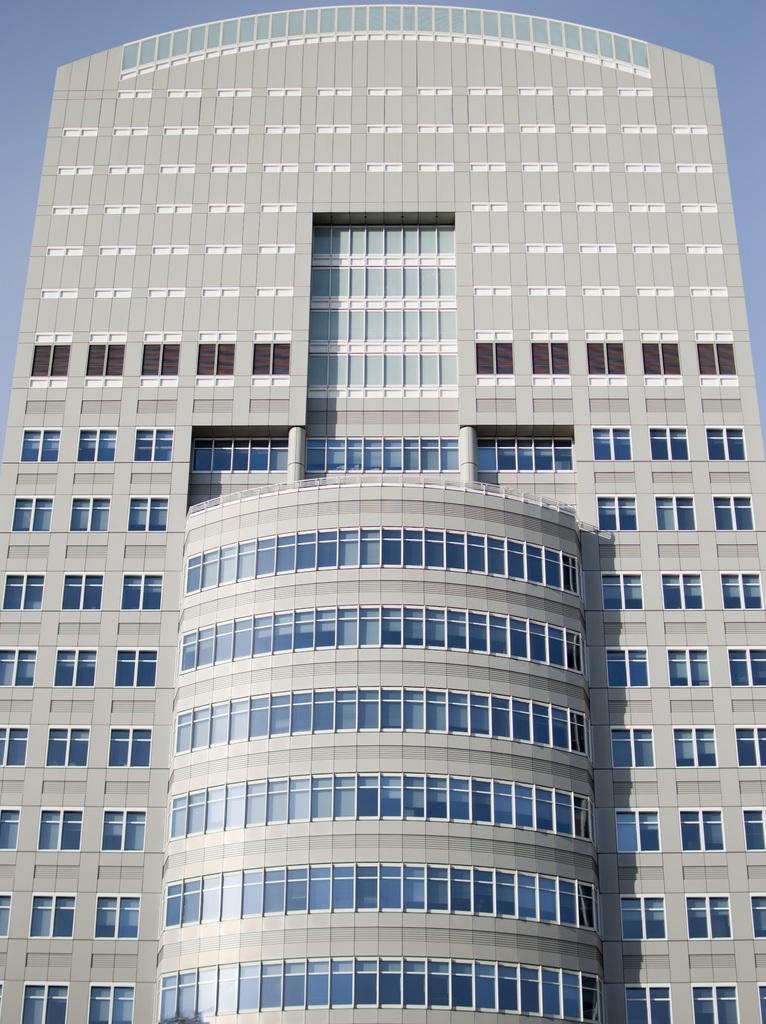Where was the picture taken? The picture was clicked outside. What is the main subject of the image? There is a building in the center of the image. What feature can be seen on the building? The building has windows. What can be seen in the background of the image? The sky is visible in the background of the image. What type of star can be seen in the aftermath of the explosion in the image? There is no explosion or star present in the image; it features a building with windows and a visible sky in the background. 